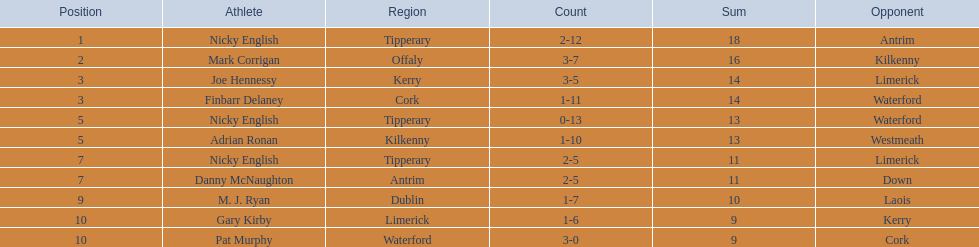I'm looking to parse the entire table for insights. Could you assist me with that? {'header': ['Position', 'Athlete', 'Region', 'Count', 'Sum', 'Opponent'], 'rows': [['1', 'Nicky English', 'Tipperary', '2-12', '18', 'Antrim'], ['2', 'Mark Corrigan', 'Offaly', '3-7', '16', 'Kilkenny'], ['3', 'Joe Hennessy', 'Kerry', '3-5', '14', 'Limerick'], ['3', 'Finbarr Delaney', 'Cork', '1-11', '14', 'Waterford'], ['5', 'Nicky English', 'Tipperary', '0-13', '13', 'Waterford'], ['5', 'Adrian Ronan', 'Kilkenny', '1-10', '13', 'Westmeath'], ['7', 'Nicky English', 'Tipperary', '2-5', '11', 'Limerick'], ['7', 'Danny McNaughton', 'Antrim', '2-5', '11', 'Down'], ['9', 'M. J. Ryan', 'Dublin', '1-7', '10', 'Laois'], ['10', 'Gary Kirby', 'Limerick', '1-6', '9', 'Kerry'], ['10', 'Pat Murphy', 'Waterford', '3-0', '9', 'Cork']]} What was the combined total of nicky english and mark corrigan? 34. 